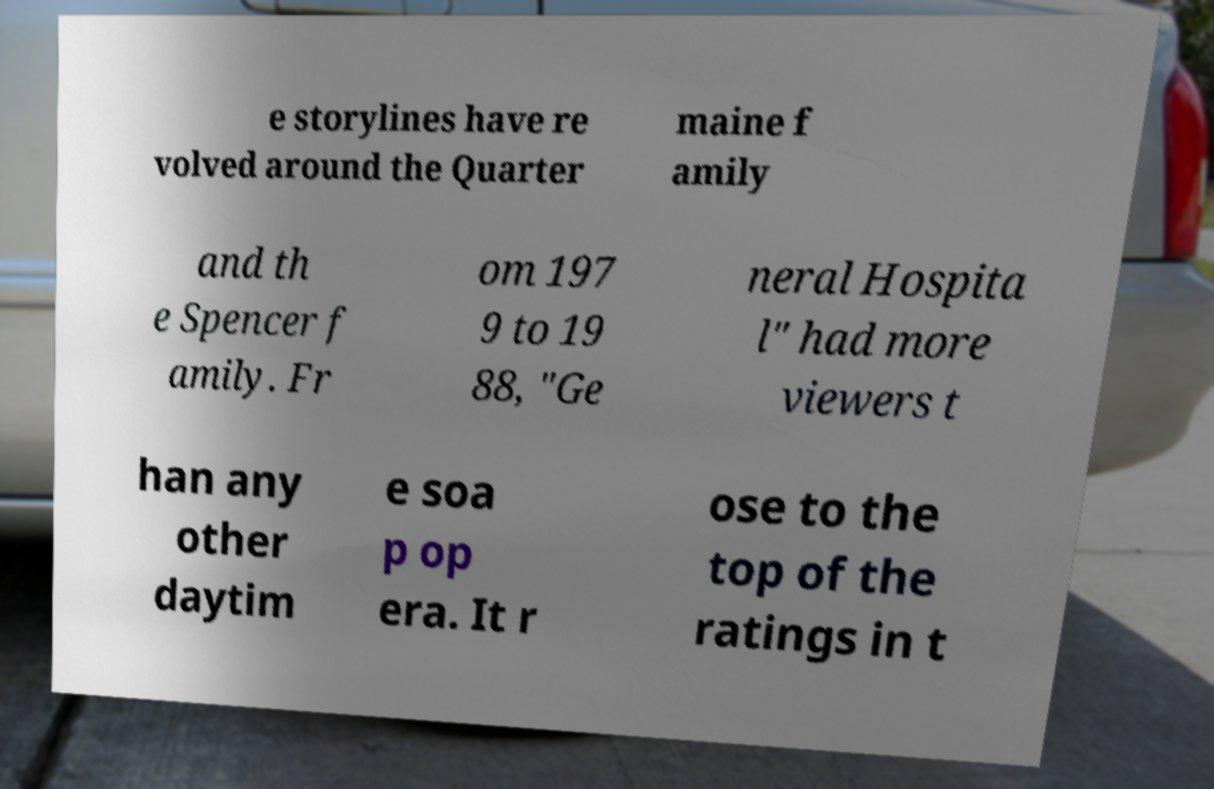For documentation purposes, I need the text within this image transcribed. Could you provide that? e storylines have re volved around the Quarter maine f amily and th e Spencer f amily. Fr om 197 9 to 19 88, "Ge neral Hospita l" had more viewers t han any other daytim e soa p op era. It r ose to the top of the ratings in t 